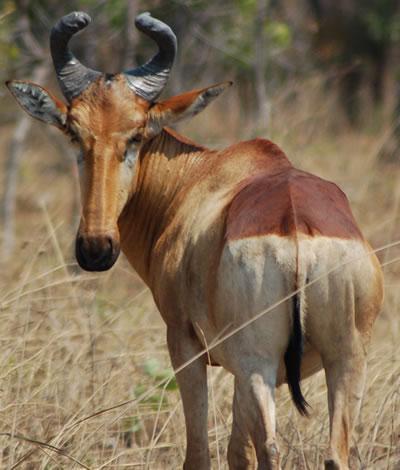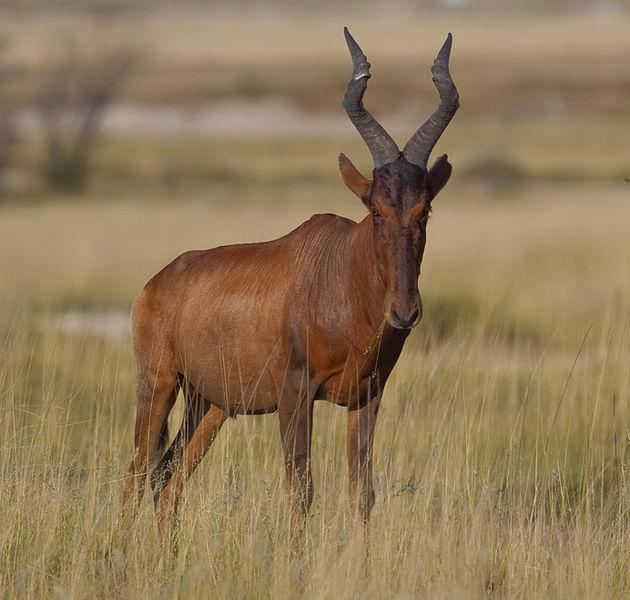The first image is the image on the left, the second image is the image on the right. Evaluate the accuracy of this statement regarding the images: "In one image, a mammal figure is behind a horned animal.". Is it true? Answer yes or no. No. 